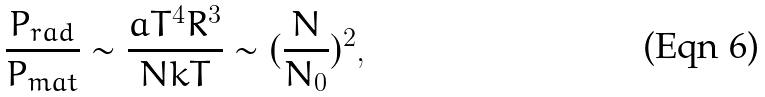Convert formula to latex. <formula><loc_0><loc_0><loc_500><loc_500>\frac { P _ { r a d } } { P _ { m a t } } \sim \frac { a T ^ { 4 } R ^ { 3 } } { N k T } \sim ( \frac { N } { N _ { 0 } } ) ^ { 2 } ,</formula> 